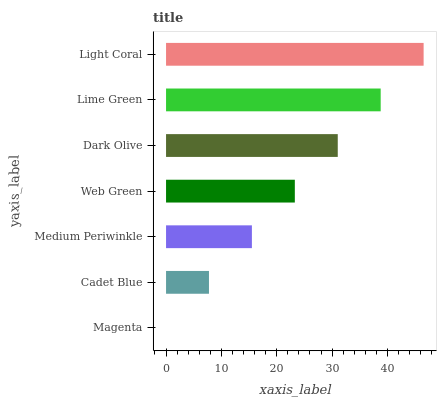Is Magenta the minimum?
Answer yes or no. Yes. Is Light Coral the maximum?
Answer yes or no. Yes. Is Cadet Blue the minimum?
Answer yes or no. No. Is Cadet Blue the maximum?
Answer yes or no. No. Is Cadet Blue greater than Magenta?
Answer yes or no. Yes. Is Magenta less than Cadet Blue?
Answer yes or no. Yes. Is Magenta greater than Cadet Blue?
Answer yes or no. No. Is Cadet Blue less than Magenta?
Answer yes or no. No. Is Web Green the high median?
Answer yes or no. Yes. Is Web Green the low median?
Answer yes or no. Yes. Is Dark Olive the high median?
Answer yes or no. No. Is Dark Olive the low median?
Answer yes or no. No. 